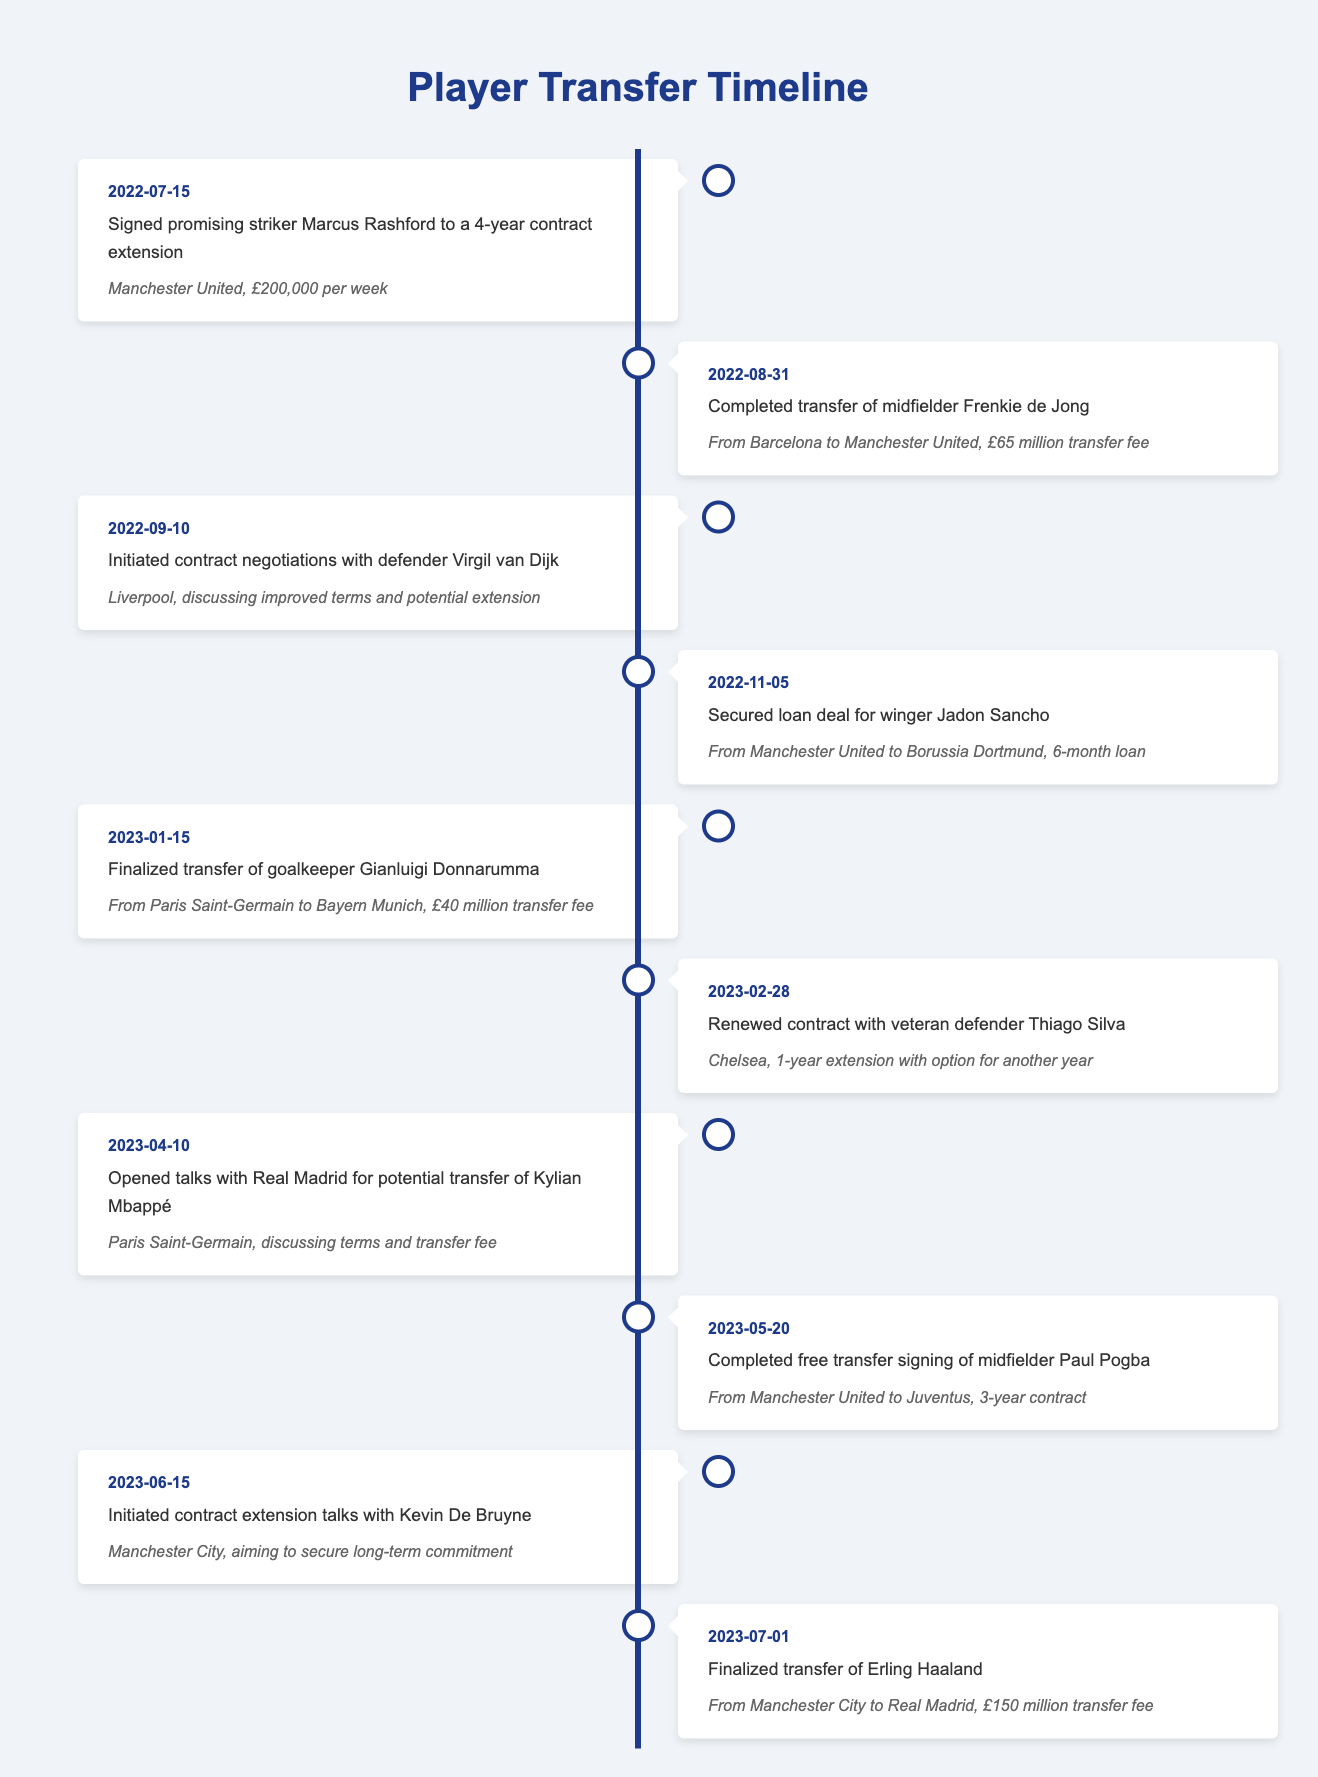What event occurred on January 15, 2023? The table shows that on January 15, 2023, the event was the finalized transfer of goalkeeper Gianluigi Donnarumma from Paris Saint-Germain to Bayern Munich for a £40 million transfer fee.
Answer: Finalized transfer of Gianluigi Donnarumma How much was the transfer fee for Frenkie de Jong? According to the table, the transfer fee for Frenkie de Jong, who transferred from Barcelona to Manchester United on August 31, 2022, was £65 million.
Answer: £65 million Was there a contract renewal for Thiago Silva? Yes, the table indicates that on February 28, 2023, Thiago Silva renewed his contract with Chelsea, signing a 1-year extension with an option for another year.
Answer: Yes Which player was involved in a loan deal, and who was the receiving club? The timeline shows that Jadon Sancho was involved in a loan deal, which took place on November 5, 2022, and the receiving club was Borussia Dortmund.
Answer: Jadon Sancho; Borussia Dortmund What is the total number of transfers listed in the timeline? By counting the events in the timeline, there are 10 transfers listed. Each event represents a unique transfer or contract negotiation, confirming this total.
Answer: 10 When did contract negotiations for Kylian Mbappé open? The table states that talks for Kylian Mbappé's potential transfer opened on April 10, 2023, with a focus on discussing terms and the transfer fee.
Answer: April 10, 2023 How many players were signed from Manchester United? From analyzing the table, it reveals three players were signed from Manchester United: Marcus Rashford (contract extension), Jadon Sancho (loan), and Paul Pogba (free transfer).
Answer: 3 Did Erling Haaland's transfer occur before or after Jadon Sancho's loan deal? The timeline shows that Erling Haaland's transfer took place on July 1, 2023, which is after the loan deal for Jadon Sancho on November 5, 2022.
Answer: After What percentage of the events in the table involved a transfer fee? Out of the 10 events, 5 involved a transfer fee, which calculates to 50% of the events. The events with fees are identified and counted for this percentage.
Answer: 50% 